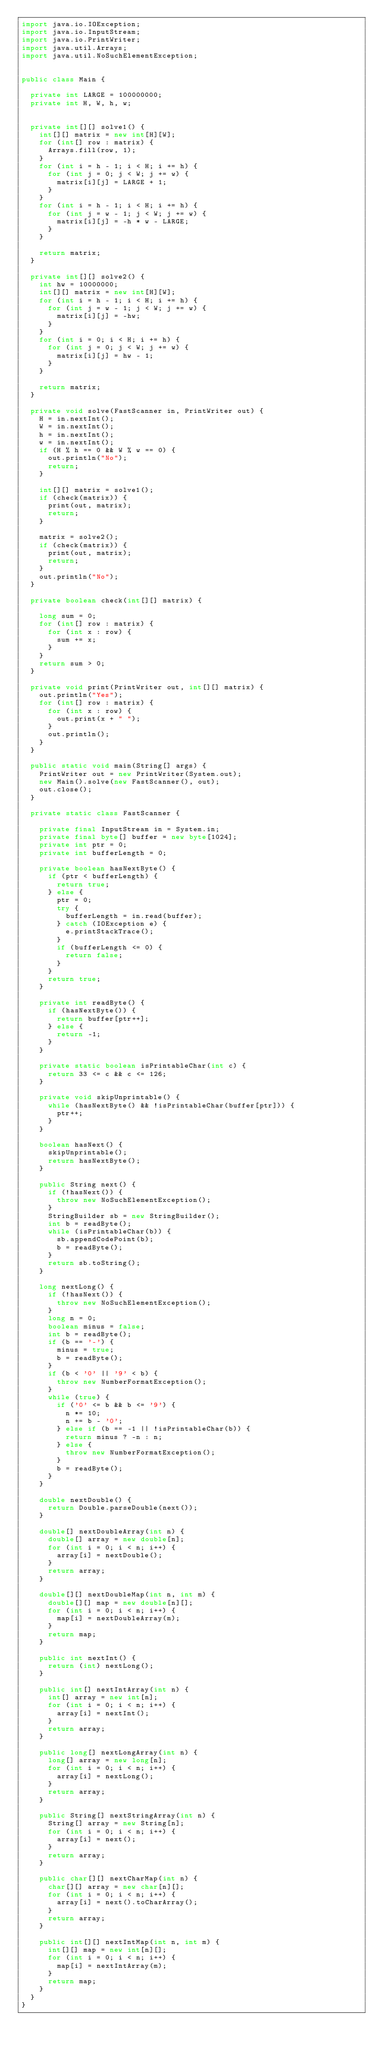<code> <loc_0><loc_0><loc_500><loc_500><_Java_>import java.io.IOException;
import java.io.InputStream;
import java.io.PrintWriter;
import java.util.Arrays;
import java.util.NoSuchElementException;


public class Main {

  private int LARGE = 100000000;
  private int H, W, h, w;


  private int[][] solve1() {
    int[][] matrix = new int[H][W];
    for (int[] row : matrix) {
      Arrays.fill(row, 1);
    }
    for (int i = h - 1; i < H; i += h) {
      for (int j = 0; j < W; j += w) {
        matrix[i][j] = LARGE + 1;
      }
    }
    for (int i = h - 1; i < H; i += h) {
      for (int j = w - 1; j < W; j += w) {
        matrix[i][j] = -h * w - LARGE;
      }
    }

    return matrix;
  }

  private int[][] solve2() {
    int hw = 10000000;
    int[][] matrix = new int[H][W];
    for (int i = h - 1; i < H; i += h) {
      for (int j = w - 1; j < W; j += w) {
        matrix[i][j] = -hw;
      }
    }
    for (int i = 0; i < H; i += h) {
      for (int j = 0; j < W; j += w) {
        matrix[i][j] = hw - 1;
      }
    }

    return matrix;
  }

  private void solve(FastScanner in, PrintWriter out) {
    H = in.nextInt();
    W = in.nextInt();
    h = in.nextInt();
    w = in.nextInt();
    if (H % h == 0 && W % w == 0) {
      out.println("No");
      return;
    }

    int[][] matrix = solve1();
    if (check(matrix)) {
      print(out, matrix);
      return;
    }

    matrix = solve2();
    if (check(matrix)) {
      print(out, matrix);
      return;
    }
    out.println("No");
  }

  private boolean check(int[][] matrix) {

    long sum = 0;
    for (int[] row : matrix) {
      for (int x : row) {
        sum += x;
      }
    }
    return sum > 0;
  }

  private void print(PrintWriter out, int[][] matrix) {
    out.println("Yes");
    for (int[] row : matrix) {
      for (int x : row) {
        out.print(x + " ");
      }
      out.println();
    }
  }

  public static void main(String[] args) {
    PrintWriter out = new PrintWriter(System.out);
    new Main().solve(new FastScanner(), out);
    out.close();
  }

  private static class FastScanner {

    private final InputStream in = System.in;
    private final byte[] buffer = new byte[1024];
    private int ptr = 0;
    private int bufferLength = 0;

    private boolean hasNextByte() {
      if (ptr < bufferLength) {
        return true;
      } else {
        ptr = 0;
        try {
          bufferLength = in.read(buffer);
        } catch (IOException e) {
          e.printStackTrace();
        }
        if (bufferLength <= 0) {
          return false;
        }
      }
      return true;
    }

    private int readByte() {
      if (hasNextByte()) {
        return buffer[ptr++];
      } else {
        return -1;
      }
    }

    private static boolean isPrintableChar(int c) {
      return 33 <= c && c <= 126;
    }

    private void skipUnprintable() {
      while (hasNextByte() && !isPrintableChar(buffer[ptr])) {
        ptr++;
      }
    }

    boolean hasNext() {
      skipUnprintable();
      return hasNextByte();
    }

    public String next() {
      if (!hasNext()) {
        throw new NoSuchElementException();
      }
      StringBuilder sb = new StringBuilder();
      int b = readByte();
      while (isPrintableChar(b)) {
        sb.appendCodePoint(b);
        b = readByte();
      }
      return sb.toString();
    }

    long nextLong() {
      if (!hasNext()) {
        throw new NoSuchElementException();
      }
      long n = 0;
      boolean minus = false;
      int b = readByte();
      if (b == '-') {
        minus = true;
        b = readByte();
      }
      if (b < '0' || '9' < b) {
        throw new NumberFormatException();
      }
      while (true) {
        if ('0' <= b && b <= '9') {
          n *= 10;
          n += b - '0';
        } else if (b == -1 || !isPrintableChar(b)) {
          return minus ? -n : n;
        } else {
          throw new NumberFormatException();
        }
        b = readByte();
      }
    }

    double nextDouble() {
      return Double.parseDouble(next());
    }

    double[] nextDoubleArray(int n) {
      double[] array = new double[n];
      for (int i = 0; i < n; i++) {
        array[i] = nextDouble();
      }
      return array;
    }

    double[][] nextDoubleMap(int n, int m) {
      double[][] map = new double[n][];
      for (int i = 0; i < n; i++) {
        map[i] = nextDoubleArray(m);
      }
      return map;
    }

    public int nextInt() {
      return (int) nextLong();
    }

    public int[] nextIntArray(int n) {
      int[] array = new int[n];
      for (int i = 0; i < n; i++) {
        array[i] = nextInt();
      }
      return array;
    }

    public long[] nextLongArray(int n) {
      long[] array = new long[n];
      for (int i = 0; i < n; i++) {
        array[i] = nextLong();
      }
      return array;
    }

    public String[] nextStringArray(int n) {
      String[] array = new String[n];
      for (int i = 0; i < n; i++) {
        array[i] = next();
      }
      return array;
    }

    public char[][] nextCharMap(int n) {
      char[][] array = new char[n][];
      for (int i = 0; i < n; i++) {
        array[i] = next().toCharArray();
      }
      return array;
    }

    public int[][] nextIntMap(int n, int m) {
      int[][] map = new int[n][];
      for (int i = 0; i < n; i++) {
        map[i] = nextIntArray(m);
      }
      return map;
    }
  }
}</code> 